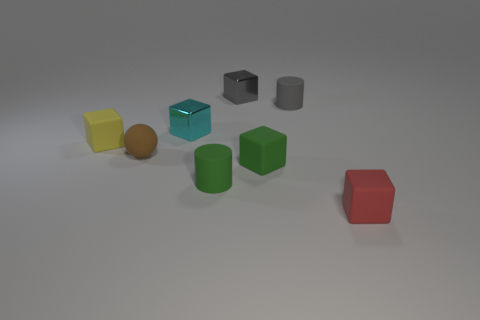What is the small brown sphere that is left of the tiny green cylinder made of?
Offer a terse response. Rubber. Is there anything else that has the same shape as the small red matte thing?
Ensure brevity in your answer.  Yes. How many metal objects are either brown balls or purple cylinders?
Your answer should be compact. 0. Is the number of cylinders that are behind the small gray matte cylinder less than the number of metallic cylinders?
Ensure brevity in your answer.  No. What shape is the small brown rubber thing that is to the left of the green object behind the tiny matte cylinder that is in front of the small brown sphere?
Make the answer very short. Sphere. Is the number of tiny yellow rubber cubes greater than the number of cyan matte balls?
Make the answer very short. Yes. What number of other objects are the same material as the tiny green block?
Offer a very short reply. 5. What number of things are either gray matte objects or small matte objects that are behind the red matte object?
Provide a succinct answer. 5. Is the number of tiny cyan things less than the number of brown matte cylinders?
Provide a succinct answer. No. What is the color of the small shiny thing that is behind the cylinder that is behind the tiny green matte thing that is in front of the green matte cube?
Your answer should be very brief. Gray. 